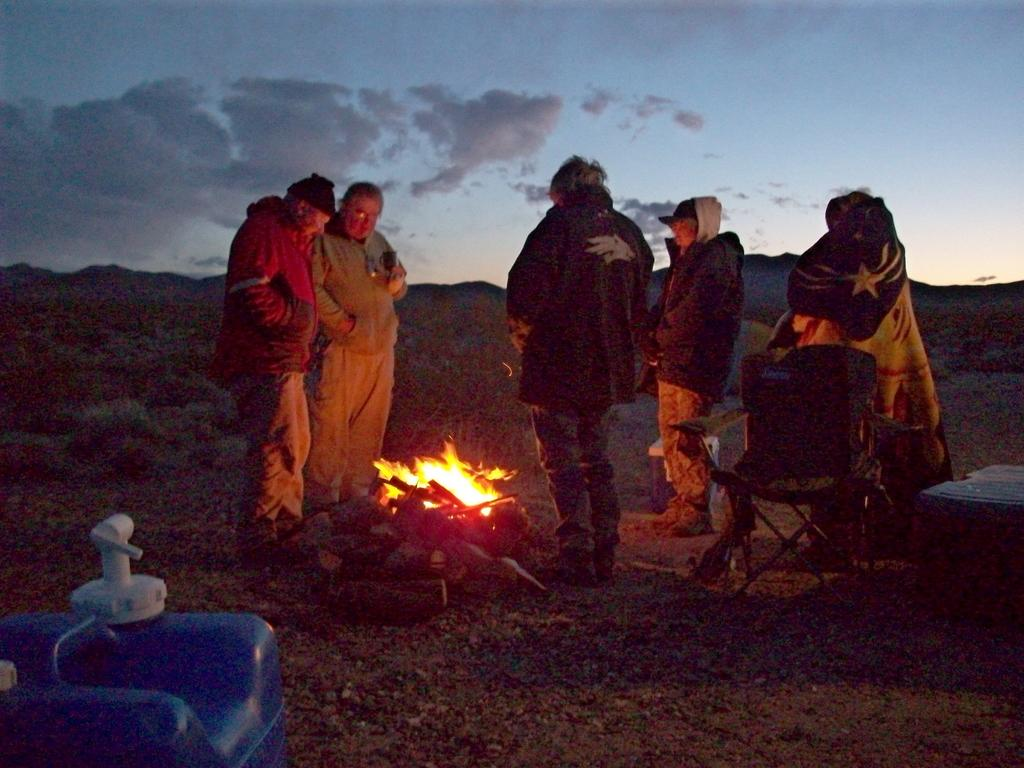What are the people in the image doing? The people in the image are standing in front of the campfire. What is located behind the people? There is a chair behind the people. Can you describe any objects related to water in the image? A water can is visible in the image. What can be seen in the distance behind the people? There are mountains, trees, and the sky visible in the background. What is the price of the quarter shown in the image? There is no quarter present in the image, so it is not possible to determine its price. 